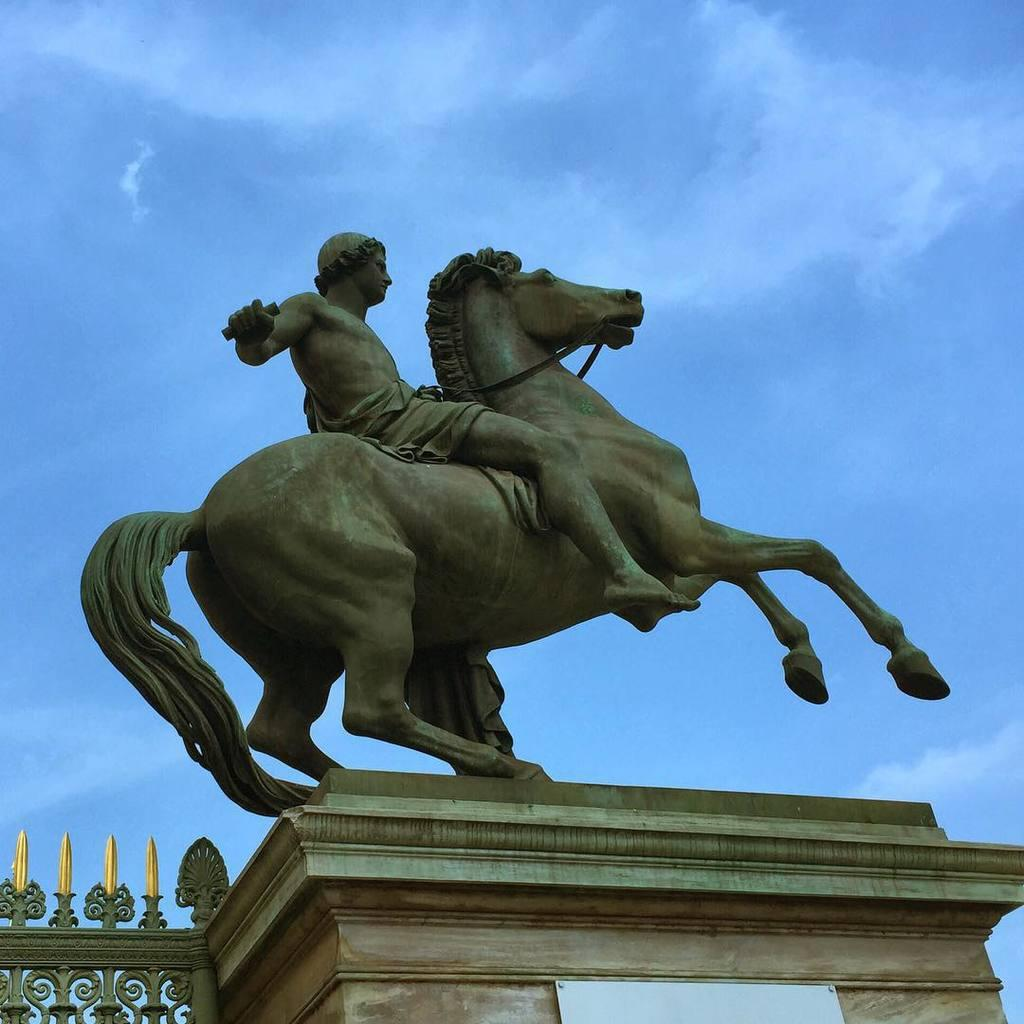What is the main subject of the statue in the image? The main subject of the statue in the image is a horse. What is the guy in the statue doing? The guy in the statue is depicted as riding the horse. What type of jam is spread on the horse's back in the image? There is no jam present in the image; it features a statue of a horse with a guy riding it. 